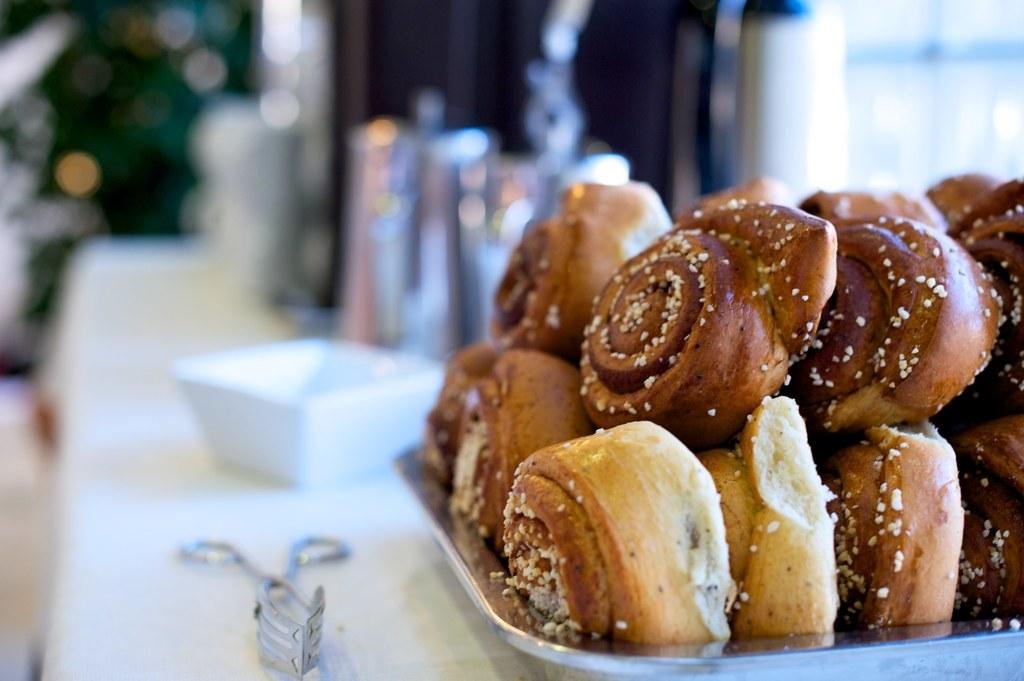What is the main object in the center of the image? There is a table in the center of the image. What is covering the table? A cloth is present on the table. What is placed on top of the cloth? There is a bowl on the table, as well as vessels and an object. What type of food can be seen on the table? The table contains an array of desserts. How is the grass used in the image? There is no grass present in the image. How many fangs can be seen on the object on the table? There is no object with fangs present in the image. 